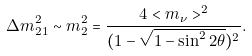Convert formula to latex. <formula><loc_0><loc_0><loc_500><loc_500>\Delta m _ { 2 1 } ^ { 2 } \sim m _ { 2 } ^ { 2 } = \frac { 4 < m _ { \nu } > ^ { 2 } } { ( 1 - \sqrt { 1 - \sin ^ { 2 } 2 \theta } ) ^ { 2 } } .</formula> 